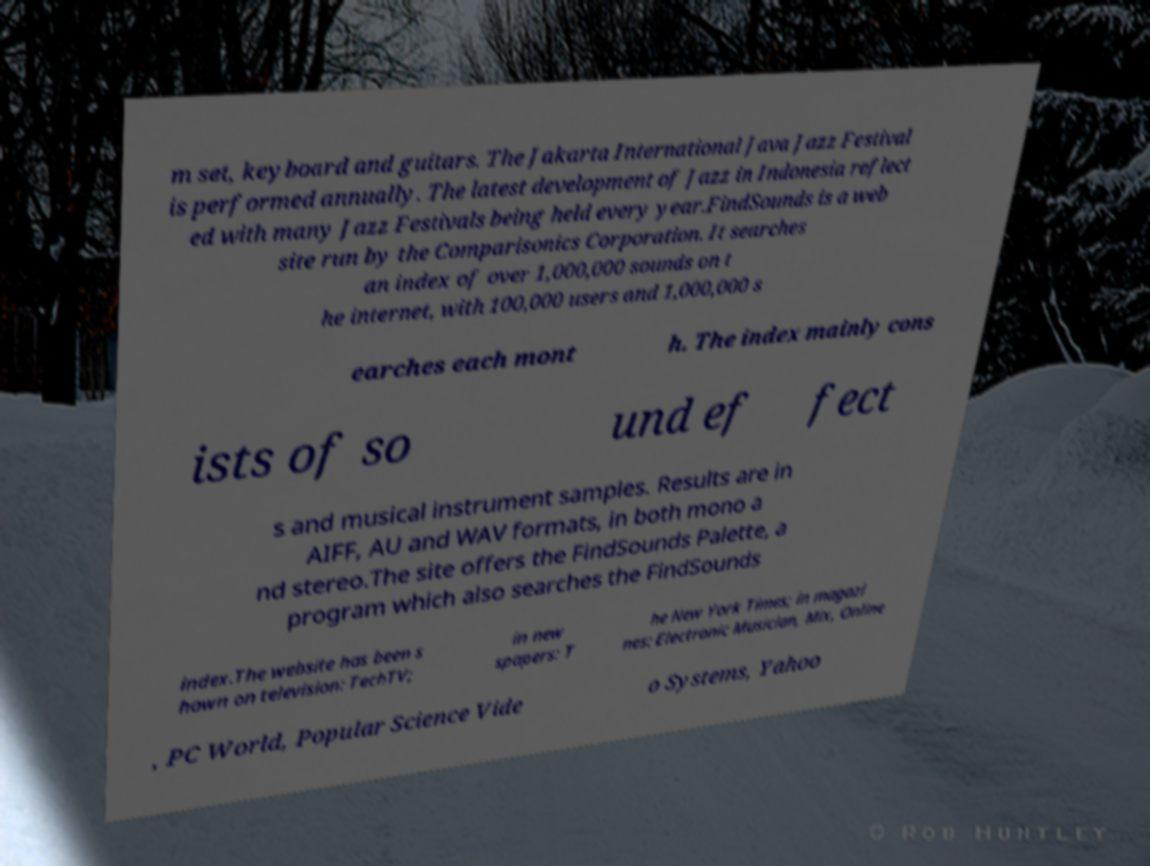I need the written content from this picture converted into text. Can you do that? m set, keyboard and guitars. The Jakarta International Java Jazz Festival is performed annually. The latest development of Jazz in Indonesia reflect ed with many Jazz Festivals being held every year.FindSounds is a web site run by the Comparisonics Corporation. It searches an index of over 1,000,000 sounds on t he internet, with 100,000 users and 1,000,000 s earches each mont h. The index mainly cons ists of so und ef fect s and musical instrument samples. Results are in AIFF, AU and WAV formats, in both mono a nd stereo.The site offers the FindSounds Palette, a program which also searches the FindSounds index.The website has been s hown on television: TechTV; in new spapers: T he New York Times; in magazi nes: Electronic Musician, Mix, Online , PC World, Popular Science Vide o Systems, Yahoo 